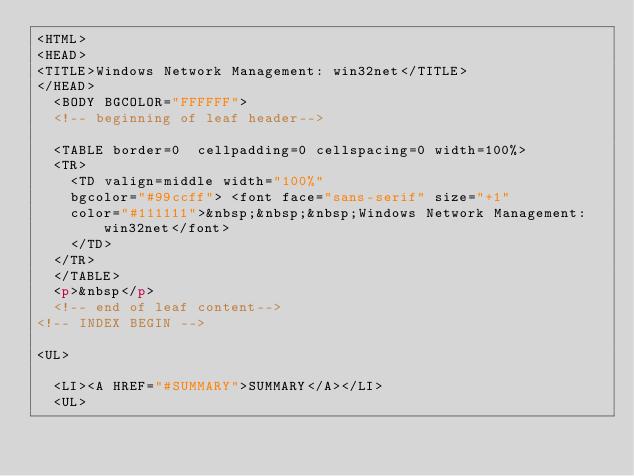<code> <loc_0><loc_0><loc_500><loc_500><_HTML_><HTML>
<HEAD>
<TITLE>Windows Network Management: win32net</TITLE>
</HEAD>
	<BODY BGCOLOR="FFFFFF">
	<!-- beginning of leaf header-->

	<TABLE border=0  cellpadding=0 cellspacing=0 width=100%>
	<TR>
		<TD valign=middle width="100%"
		bgcolor="#99ccff"> <font face="sans-serif" size="+1"
		color="#111111">&nbsp;&nbsp;&nbsp;Windows Network Management: win32net</font>
		</TD>
	</TR>
	</TABLE>
	<p>&nbsp</p>
	<!-- end of leaf content-->
<!-- INDEX BEGIN -->

<UL>

	<LI><A HREF="#SUMMARY">SUMMARY</A></LI>
	<UL></code> 